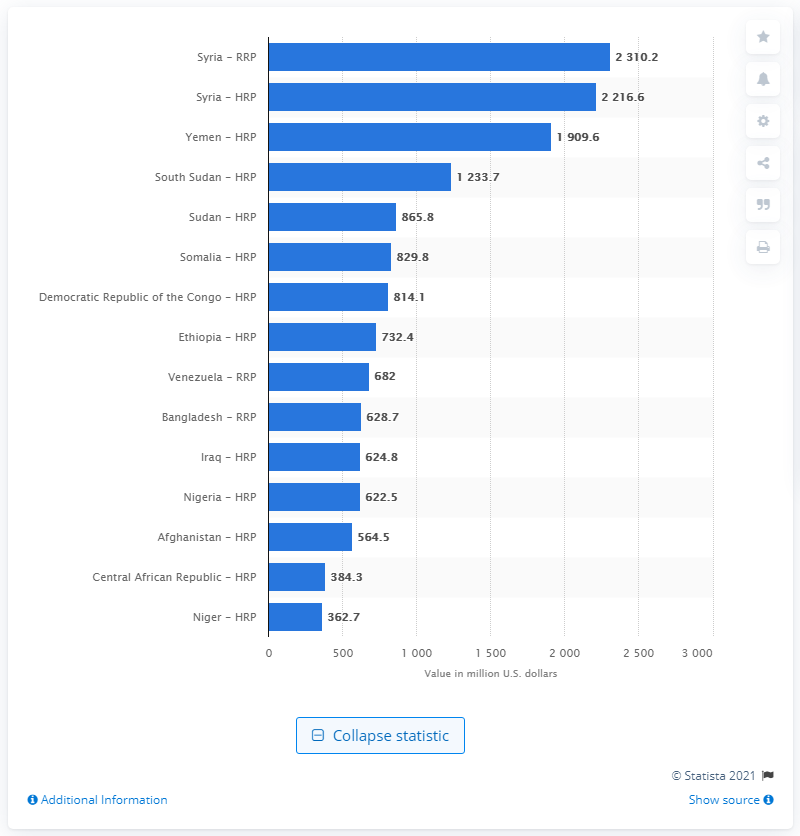Draw attention to some important aspects in this diagram. In 2020, Yemen received approximately $1909.6 million in aid. 